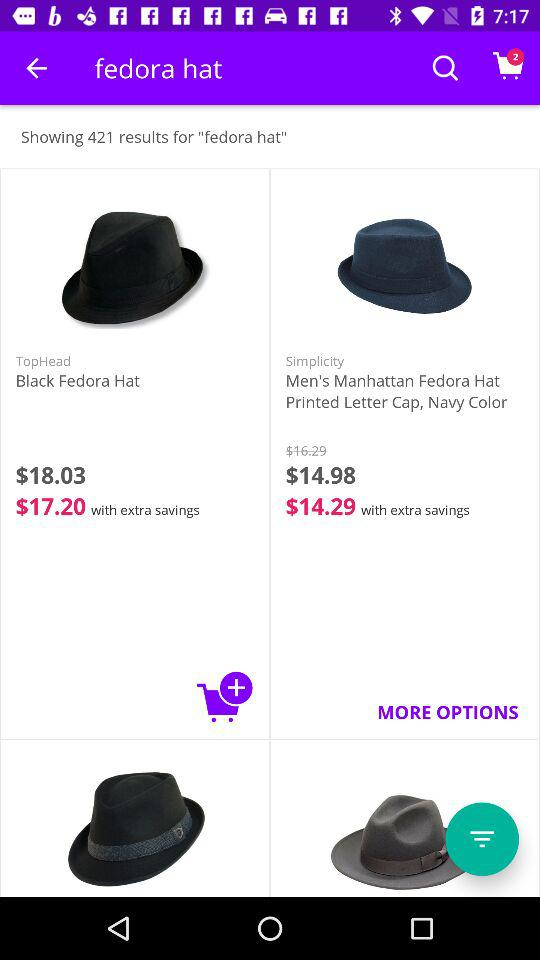How many items are in the cart?
Answer the question using a single word or phrase. 2 